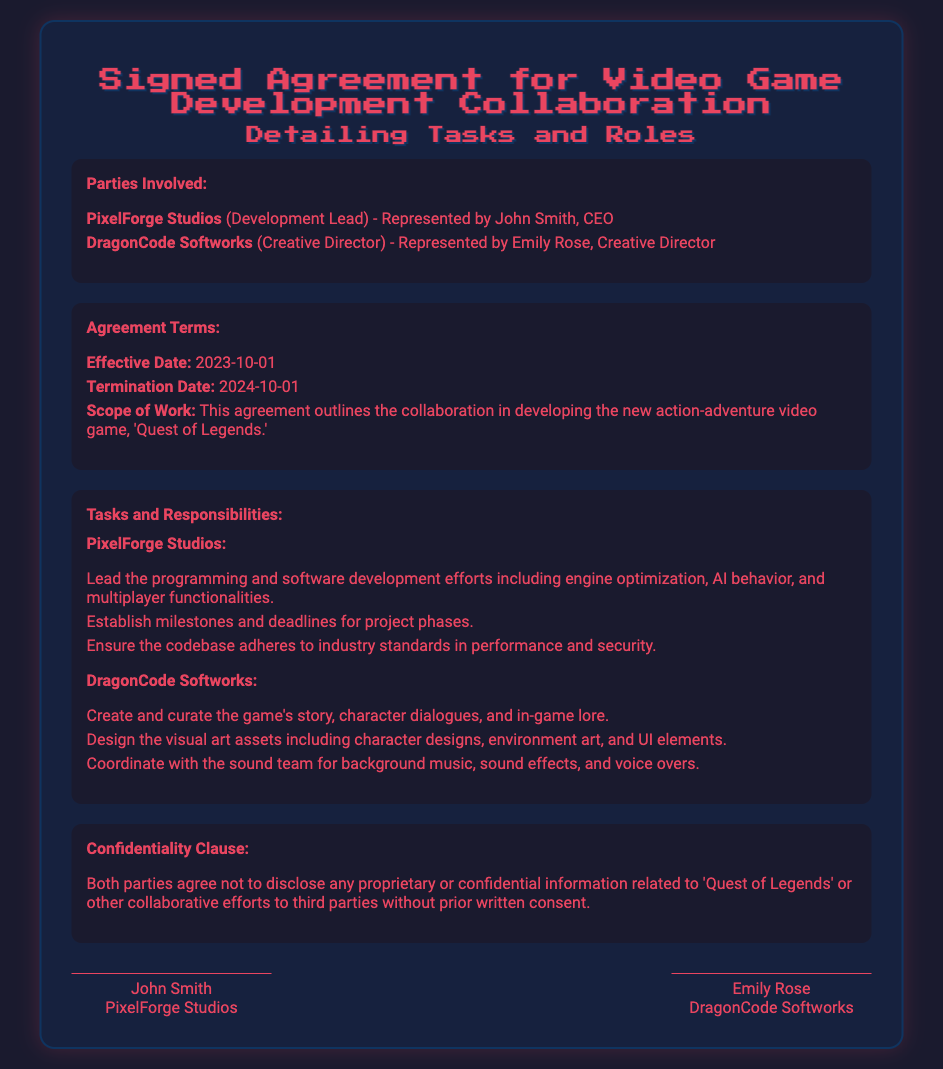What is the effective date of the agreement? The effective date of the agreement is specified in the terms section of the document.
Answer: 2023-10-01 Who represents PixelForge Studios? The document names individuals representing each party involved in the agreement.
Answer: John Smith What is the termination date of this agreement? The termination date of the agreement is mentioned in the terms section.
Answer: 2024-10-01 What is the title of the video game being developed? The document mentions the title of the game within the scope of work.
Answer: Quest of Legends What is one responsibility of PixelForge Studios? The document specifies tasks assigned to each party, including PixelForge Studios.
Answer: Lead the programming and software development efforts What is a task assigned to DragonCode Softworks? DragonCode Softworks has specific duties listed in the tasks section of the document.
Answer: Create and curate the game's story What clause is included regarding confidential information? The document includes a specific clause related to the confidentiality of shared information.
Answer: Confidentiality Clause How many parties are involved in this agreement? The document describes the parties entered into the agreement.
Answer: Two 